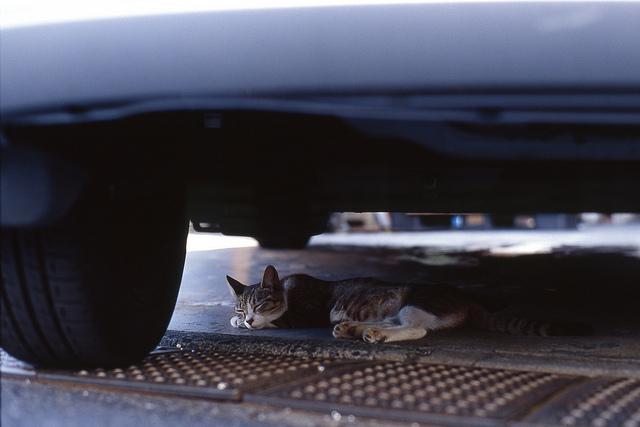What color is the car?
Quick response, please. White. Who looks content?
Give a very brief answer. Cat. Is the car moving?
Write a very short answer. No. 